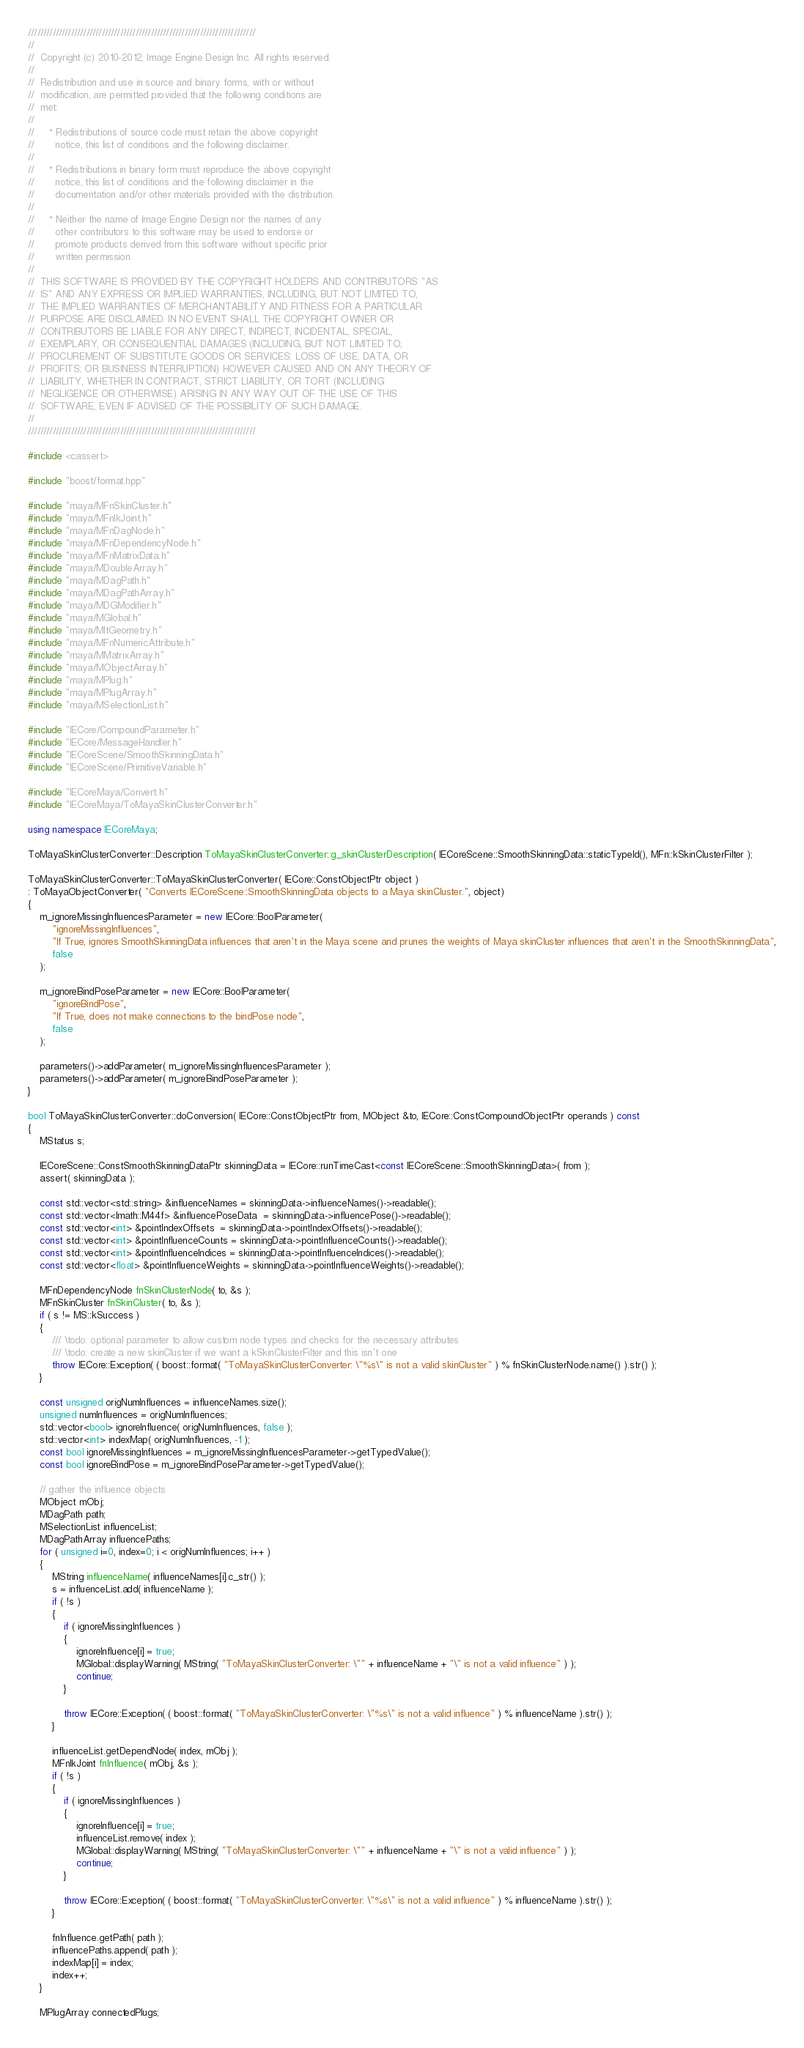Convert code to text. <code><loc_0><loc_0><loc_500><loc_500><_C++_>//////////////////////////////////////////////////////////////////////////
//
//  Copyright (c) 2010-2012, Image Engine Design Inc. All rights reserved.
//
//  Redistribution and use in source and binary forms, with or without
//  modification, are permitted provided that the following conditions are
//  met:
//
//     * Redistributions of source code must retain the above copyright
//       notice, this list of conditions and the following disclaimer.
//
//     * Redistributions in binary form must reproduce the above copyright
//       notice, this list of conditions and the following disclaimer in the
//       documentation and/or other materials provided with the distribution.
//
//     * Neither the name of Image Engine Design nor the names of any
//       other contributors to this software may be used to endorse or
//       promote products derived from this software without specific prior
//       written permission.
//
//  THIS SOFTWARE IS PROVIDED BY THE COPYRIGHT HOLDERS AND CONTRIBUTORS "AS
//  IS" AND ANY EXPRESS OR IMPLIED WARRANTIES, INCLUDING, BUT NOT LIMITED TO,
//  THE IMPLIED WARRANTIES OF MERCHANTABILITY AND FITNESS FOR A PARTICULAR
//  PURPOSE ARE DISCLAIMED. IN NO EVENT SHALL THE COPYRIGHT OWNER OR
//  CONTRIBUTORS BE LIABLE FOR ANY DIRECT, INDIRECT, INCIDENTAL, SPECIAL,
//  EXEMPLARY, OR CONSEQUENTIAL DAMAGES (INCLUDING, BUT NOT LIMITED TO,
//  PROCUREMENT OF SUBSTITUTE GOODS OR SERVICES; LOSS OF USE, DATA, OR
//  PROFITS; OR BUSINESS INTERRUPTION) HOWEVER CAUSED AND ON ANY THEORY OF
//  LIABILITY, WHETHER IN CONTRACT, STRICT LIABILITY, OR TORT (INCLUDING
//  NEGLIGENCE OR OTHERWISE) ARISING IN ANY WAY OUT OF THE USE OF THIS
//  SOFTWARE, EVEN IF ADVISED OF THE POSSIBILITY OF SUCH DAMAGE.
//
//////////////////////////////////////////////////////////////////////////

#include <cassert>

#include "boost/format.hpp"

#include "maya/MFnSkinCluster.h"
#include "maya/MFnIkJoint.h"
#include "maya/MFnDagNode.h"
#include "maya/MFnDependencyNode.h"
#include "maya/MFnMatrixData.h"
#include "maya/MDoubleArray.h"
#include "maya/MDagPath.h"
#include "maya/MDagPathArray.h"
#include "maya/MDGModifier.h"
#include "maya/MGlobal.h"
#include "maya/MItGeometry.h"
#include "maya/MFnNumericAttribute.h"
#include "maya/MMatrixArray.h"
#include "maya/MObjectArray.h"
#include "maya/MPlug.h"
#include "maya/MPlugArray.h"
#include "maya/MSelectionList.h"

#include "IECore/CompoundParameter.h"
#include "IECore/MessageHandler.h"
#include "IECoreScene/SmoothSkinningData.h"
#include "IECoreScene/PrimitiveVariable.h"

#include "IECoreMaya/Convert.h"
#include "IECoreMaya/ToMayaSkinClusterConverter.h"

using namespace IECoreMaya;

ToMayaSkinClusterConverter::Description ToMayaSkinClusterConverter::g_skinClusterDescription( IECoreScene::SmoothSkinningData::staticTypeId(), MFn::kSkinClusterFilter );

ToMayaSkinClusterConverter::ToMayaSkinClusterConverter( IECore::ConstObjectPtr object )
: ToMayaObjectConverter( "Converts IECoreScene::SmoothSkinningData objects to a Maya skinCluster.", object)
{
	m_ignoreMissingInfluencesParameter = new IECore::BoolParameter(
		"ignoreMissingInfluences",
		"If True, ignores SmoothSkinningData influences that aren't in the Maya scene and prunes the weights of Maya skinCluster influences that aren't in the SmoothSkinningData",
		false
	);

	m_ignoreBindPoseParameter = new IECore::BoolParameter(
		"ignoreBindPose",
		"If True, does not make connections to the bindPose node",
		false
	);

	parameters()->addParameter( m_ignoreMissingInfluencesParameter );
	parameters()->addParameter( m_ignoreBindPoseParameter );
}

bool ToMayaSkinClusterConverter::doConversion( IECore::ConstObjectPtr from, MObject &to, IECore::ConstCompoundObjectPtr operands ) const
{
	MStatus s;

	IECoreScene::ConstSmoothSkinningDataPtr skinningData = IECore::runTimeCast<const IECoreScene::SmoothSkinningData>( from );
	assert( skinningData );

	const std::vector<std::string> &influenceNames = skinningData->influenceNames()->readable();
	const std::vector<Imath::M44f> &influencePoseData  = skinningData->influencePose()->readable();
	const std::vector<int> &pointIndexOffsets  = skinningData->pointIndexOffsets()->readable();
	const std::vector<int> &pointInfluenceCounts = skinningData->pointInfluenceCounts()->readable();
	const std::vector<int> &pointInfluenceIndices = skinningData->pointInfluenceIndices()->readable();
	const std::vector<float> &pointInfluenceWeights = skinningData->pointInfluenceWeights()->readable();

	MFnDependencyNode fnSkinClusterNode( to, &s );
	MFnSkinCluster fnSkinCluster( to, &s );
	if ( s != MS::kSuccess )
	{
		/// \todo: optional parameter to allow custom node types and checks for the necessary attributes
		/// \todo: create a new skinCluster if we want a kSkinClusterFilter and this isn't one
		throw IECore::Exception( ( boost::format( "ToMayaSkinClusterConverter: \"%s\" is not a valid skinCluster" ) % fnSkinClusterNode.name() ).str() );
	}

	const unsigned origNumInfluences = influenceNames.size();
	unsigned numInfluences = origNumInfluences;
	std::vector<bool> ignoreInfluence( origNumInfluences, false );
	std::vector<int> indexMap( origNumInfluences, -1 );
	const bool ignoreMissingInfluences = m_ignoreMissingInfluencesParameter->getTypedValue();
	const bool ignoreBindPose = m_ignoreBindPoseParameter->getTypedValue();

	// gather the influence objects
	MObject mObj;
	MDagPath path;
	MSelectionList influenceList;
	MDagPathArray influencePaths;
	for ( unsigned i=0, index=0; i < origNumInfluences; i++ )
	{
		MString influenceName( influenceNames[i].c_str() );
		s = influenceList.add( influenceName );
		if ( !s )
		{
			if ( ignoreMissingInfluences )
			{
				ignoreInfluence[i] = true;
				MGlobal::displayWarning( MString( "ToMayaSkinClusterConverter: \"" + influenceName + "\" is not a valid influence" ) );
				continue;
			}

			throw IECore::Exception( ( boost::format( "ToMayaSkinClusterConverter: \"%s\" is not a valid influence" ) % influenceName ).str() );
		}

		influenceList.getDependNode( index, mObj );
		MFnIkJoint fnInfluence( mObj, &s );
		if ( !s )
		{
			if ( ignoreMissingInfluences )
			{
				ignoreInfluence[i] = true;
				influenceList.remove( index );
				MGlobal::displayWarning( MString( "ToMayaSkinClusterConverter: \"" + influenceName + "\" is not a valid influence" ) );
				continue;
			}

			throw IECore::Exception( ( boost::format( "ToMayaSkinClusterConverter: \"%s\" is not a valid influence" ) % influenceName ).str() );
		}

		fnInfluence.getPath( path );
		influencePaths.append( path );
		indexMap[i] = index;
		index++;
	}

	MPlugArray connectedPlugs;
</code> 